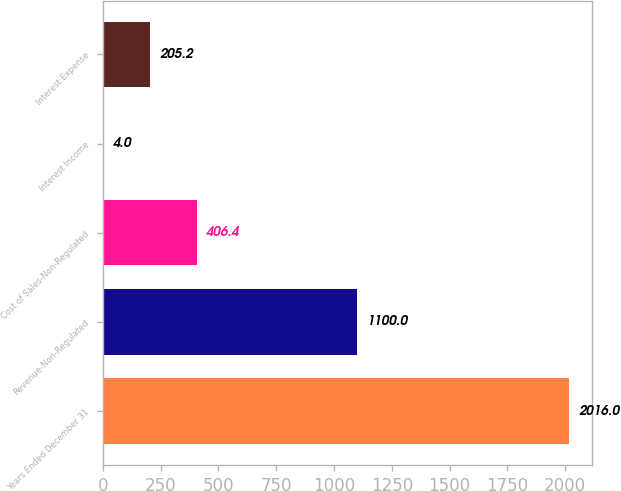Convert chart to OTSL. <chart><loc_0><loc_0><loc_500><loc_500><bar_chart><fcel>Years Ended December 31<fcel>Revenue-Non-Regulated<fcel>Cost of Sales-Non-Regulated<fcel>Interest Income<fcel>Interest Expense<nl><fcel>2016<fcel>1100<fcel>406.4<fcel>4<fcel>205.2<nl></chart> 